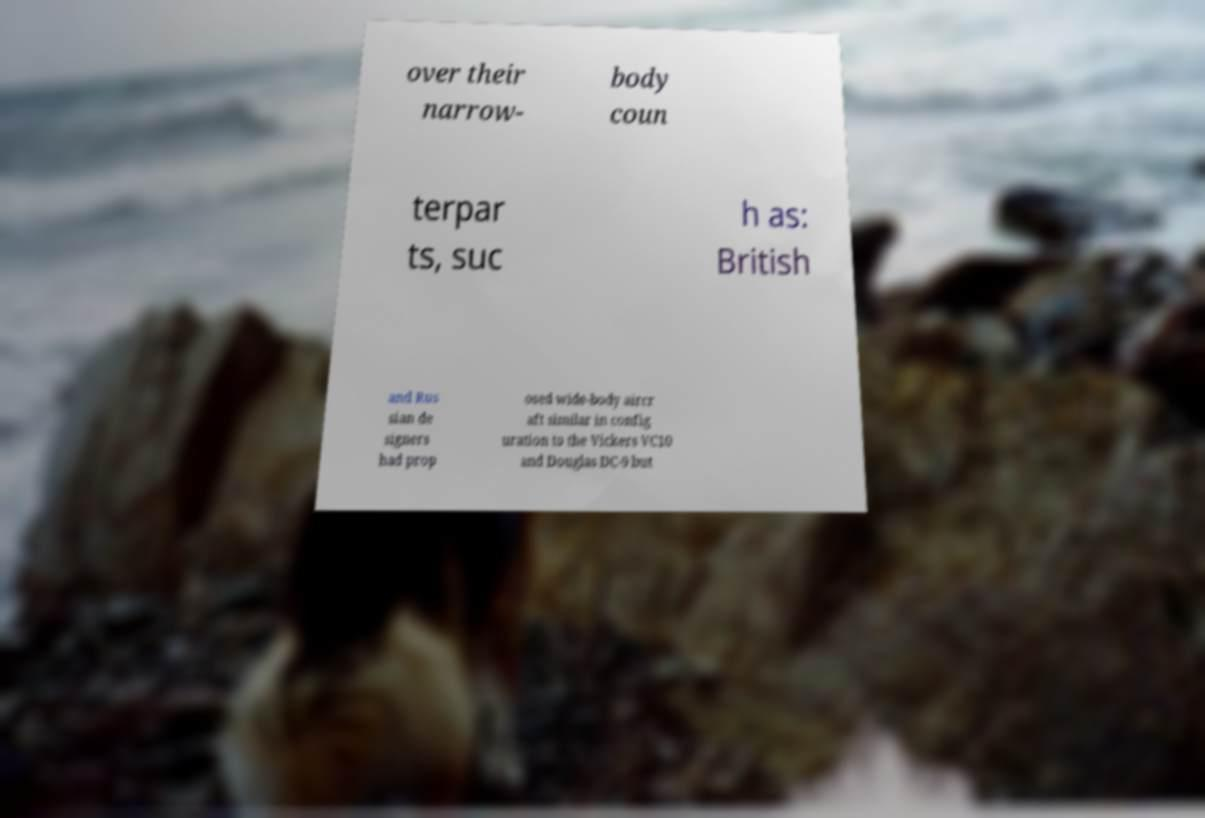Please identify and transcribe the text found in this image. over their narrow- body coun terpar ts, suc h as: British and Rus sian de signers had prop osed wide-body aircr aft similar in config uration to the Vickers VC10 and Douglas DC-9 but 